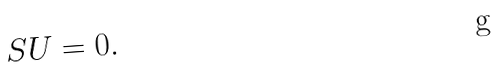<formula> <loc_0><loc_0><loc_500><loc_500>S U = 0 .</formula> 